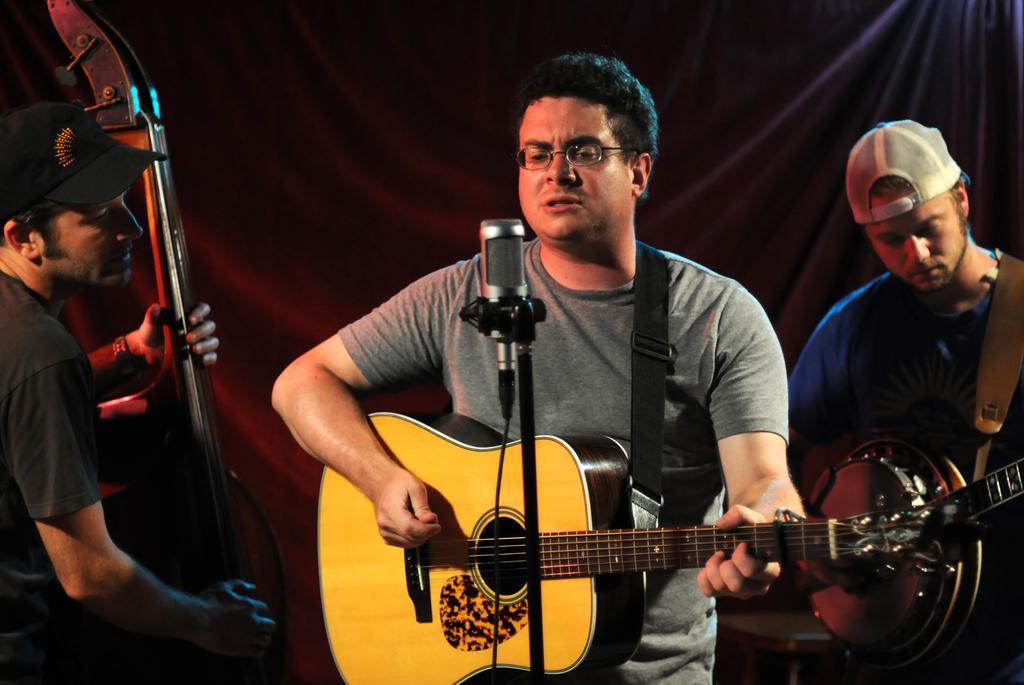In one or two sentences, can you explain what this image depicts? In this picture we can see three persons who are playing guitars. This is mike. He has spectacles and he wear a cap. 